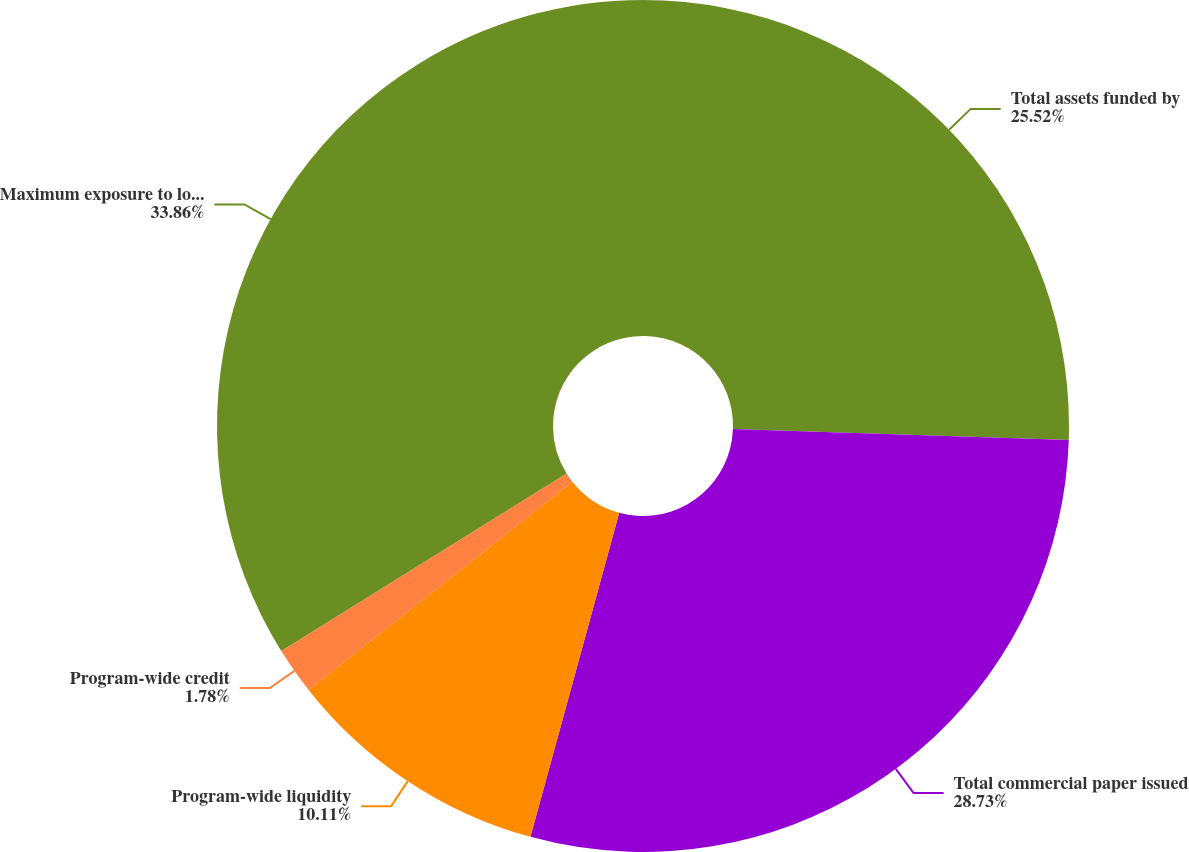Convert chart to OTSL. <chart><loc_0><loc_0><loc_500><loc_500><pie_chart><fcel>Total assets funded by<fcel>Total commercial paper issued<fcel>Program-wide liquidity<fcel>Program-wide credit<fcel>Maximum exposure to loss (a)<nl><fcel>25.52%<fcel>28.73%<fcel>10.11%<fcel>1.78%<fcel>33.85%<nl></chart> 